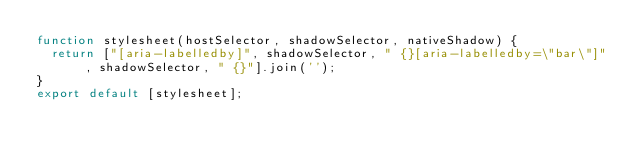Convert code to text. <code><loc_0><loc_0><loc_500><loc_500><_JavaScript_>function stylesheet(hostSelector, shadowSelector, nativeShadow) {
  return ["[aria-labelledby]", shadowSelector, " {}[aria-labelledby=\"bar\"]", shadowSelector, " {}"].join('');
}
export default [stylesheet];</code> 